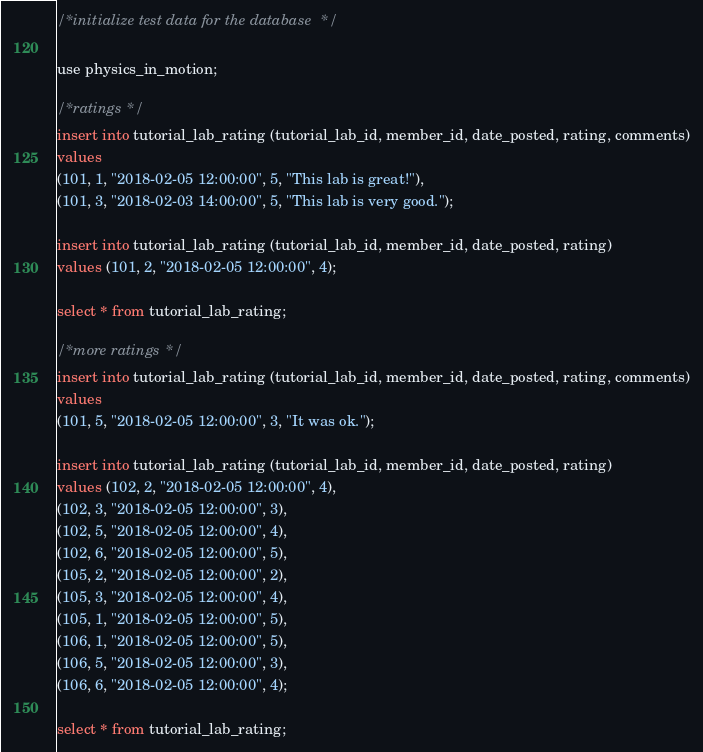<code> <loc_0><loc_0><loc_500><loc_500><_SQL_>/* initialize test data for the database */

use physics_in_motion;

/* ratings */
insert into tutorial_lab_rating (tutorial_lab_id, member_id, date_posted, rating, comments)
values 
(101, 1, "2018-02-05 12:00:00", 5, "This lab is great!"),
(101, 3, "2018-02-03 14:00:00", 5, "This lab is very good.");

insert into tutorial_lab_rating (tutorial_lab_id, member_id, date_posted, rating)
values (101, 2, "2018-02-05 12:00:00", 4);

select * from tutorial_lab_rating;

/* more ratings */
insert into tutorial_lab_rating (tutorial_lab_id, member_id, date_posted, rating, comments)
values 
(101, 5, "2018-02-05 12:00:00", 3, "It was ok.");

insert into tutorial_lab_rating (tutorial_lab_id, member_id, date_posted, rating)
values (102, 2, "2018-02-05 12:00:00", 4),
(102, 3, "2018-02-05 12:00:00", 3),
(102, 5, "2018-02-05 12:00:00", 4),
(102, 6, "2018-02-05 12:00:00", 5),
(105, 2, "2018-02-05 12:00:00", 2),
(105, 3, "2018-02-05 12:00:00", 4),
(105, 1, "2018-02-05 12:00:00", 5),
(106, 1, "2018-02-05 12:00:00", 5),
(106, 5, "2018-02-05 12:00:00", 3),
(106, 6, "2018-02-05 12:00:00", 4);

select * from tutorial_lab_rating;
</code> 